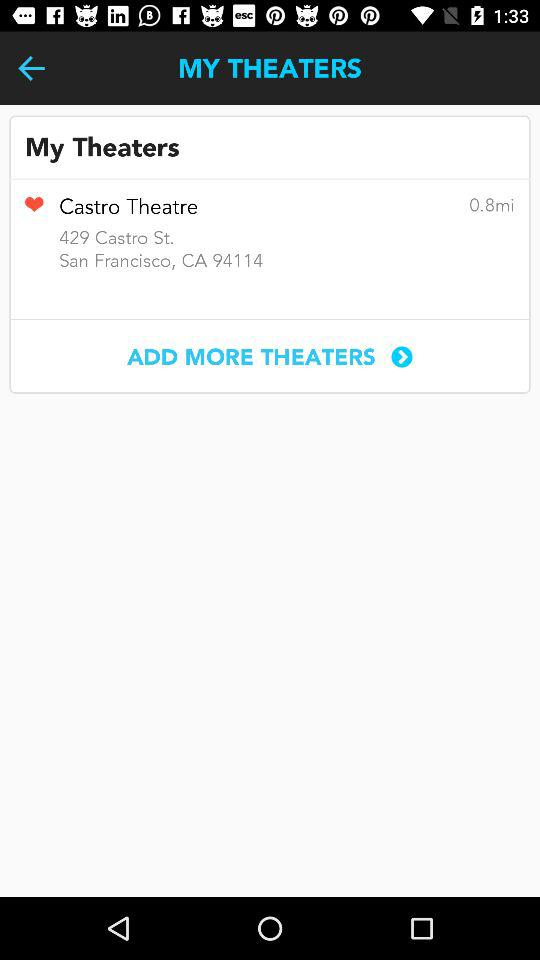How many miles away is the theater?
Answer the question using a single word or phrase. 0.8 